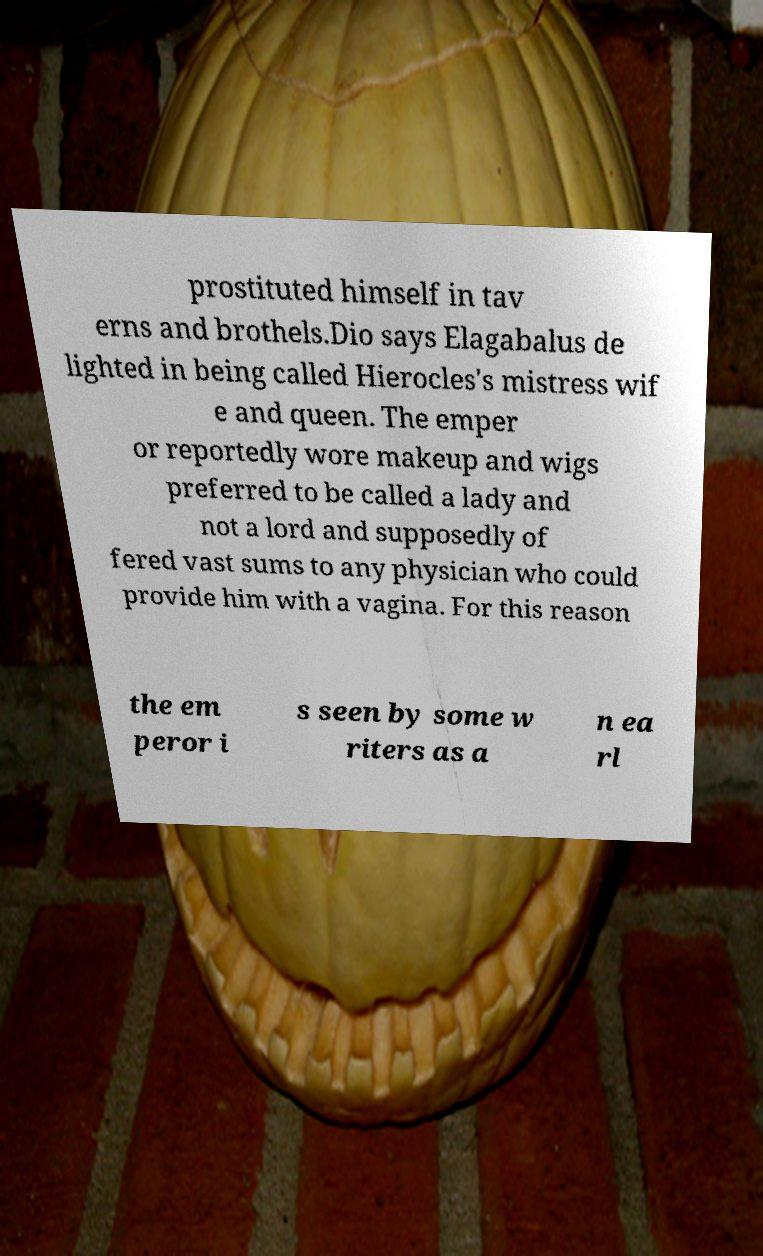Could you assist in decoding the text presented in this image and type it out clearly? prostituted himself in tav erns and brothels.Dio says Elagabalus de lighted in being called Hierocles's mistress wif e and queen. The emper or reportedly wore makeup and wigs preferred to be called a lady and not a lord and supposedly of fered vast sums to any physician who could provide him with a vagina. For this reason the em peror i s seen by some w riters as a n ea rl 